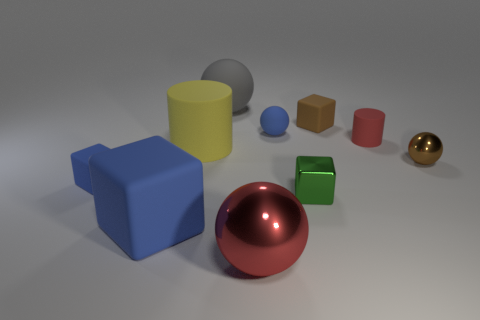Subtract all big blocks. How many blocks are left? 3 Subtract all brown spheres. How many spheres are left? 3 Subtract 1 blocks. How many blocks are left? 3 Subtract all blocks. How many objects are left? 6 Add 2 red cylinders. How many red cylinders are left? 3 Add 7 green blocks. How many green blocks exist? 8 Subtract 0 purple cylinders. How many objects are left? 10 Subtract all purple blocks. Subtract all blue spheres. How many blocks are left? 4 Subtract all red cylinders. How many cyan cubes are left? 0 Subtract all green metallic blocks. Subtract all small blue cubes. How many objects are left? 8 